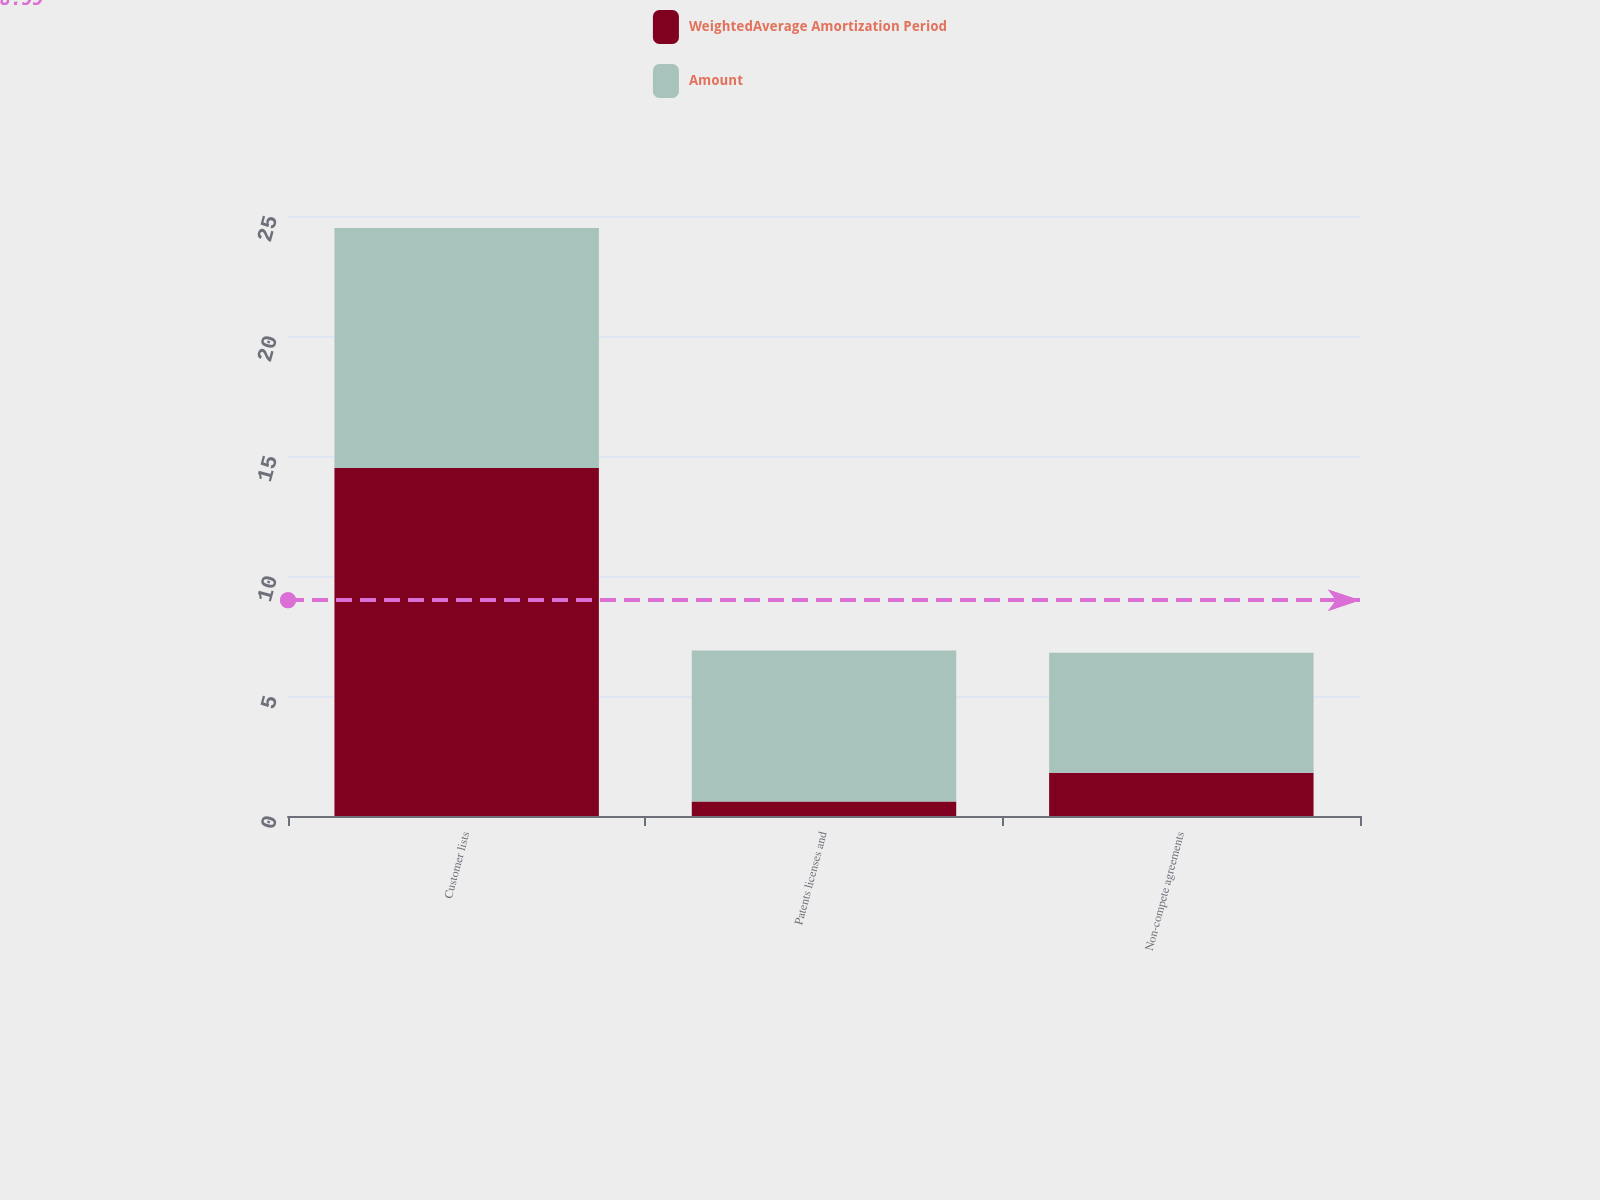Convert chart to OTSL. <chart><loc_0><loc_0><loc_500><loc_500><stacked_bar_chart><ecel><fcel>Customer lists<fcel>Patents licenses and<fcel>Non-compete agreements<nl><fcel>WeightedAverage Amortization Period<fcel>14.5<fcel>0.6<fcel>1.8<nl><fcel>Amount<fcel>10<fcel>6.3<fcel>5<nl></chart> 